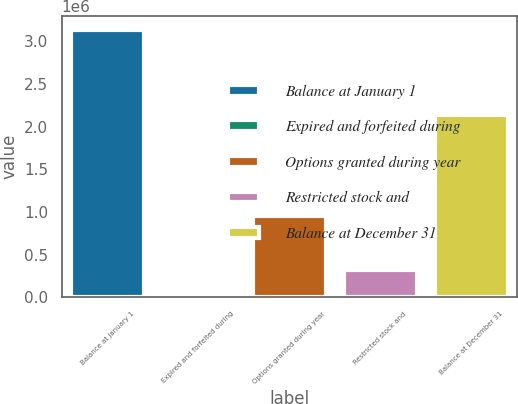Convert chart. <chart><loc_0><loc_0><loc_500><loc_500><bar_chart><fcel>Balance at January 1<fcel>Expired and forfeited during<fcel>Options granted during year<fcel>Restricted stock and<fcel>Balance at December 31<nl><fcel>3.136e+06<fcel>8000<fcel>949750<fcel>320800<fcel>2.13681e+06<nl></chart> 